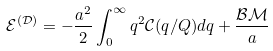<formula> <loc_0><loc_0><loc_500><loc_500>\mathcal { E } ^ { ( \mathcal { D } ) } = - \frac { a ^ { 2 } } { 2 } \int _ { 0 } ^ { \infty } q ^ { 2 } \mathcal { C } ( q / Q ) d q + \frac { \mathcal { B M } } { a }</formula> 